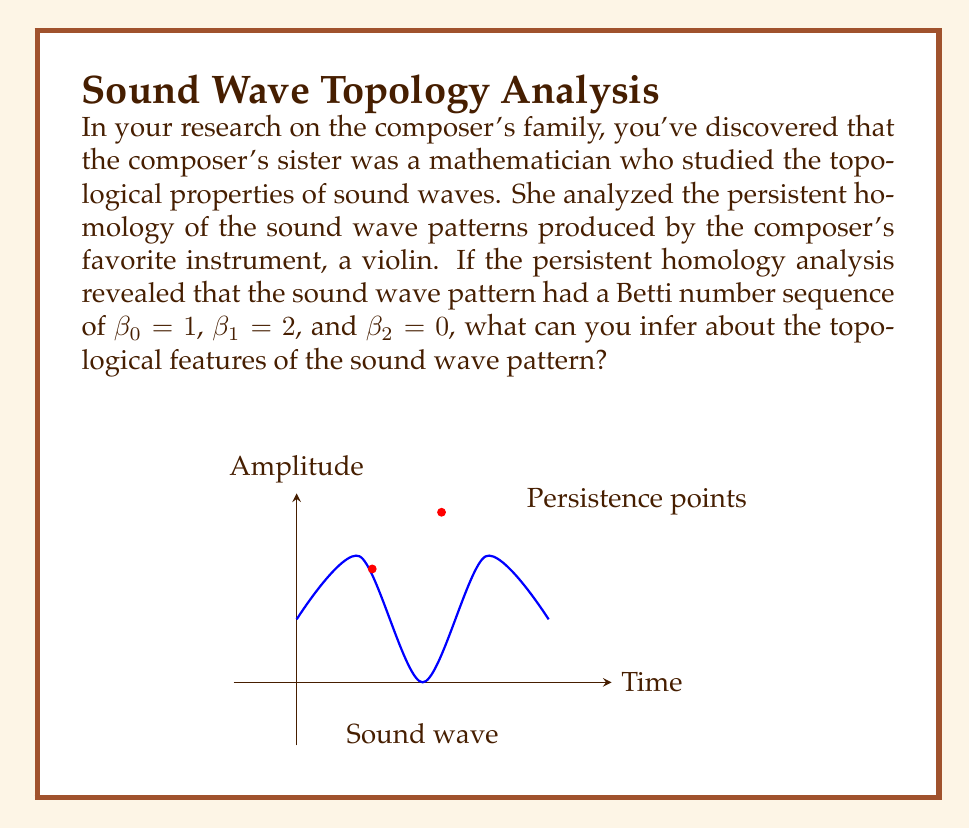Solve this math problem. To interpret the Betti number sequence in the context of persistent homology for sound wave patterns, let's break it down step-by-step:

1) Betti numbers in persistent homology represent different topological features:
   - $\beta_0$ represents the number of connected components
   - $\beta_1$ represents the number of 1-dimensional holes or loops
   - $\beta_2$ represents the number of 2-dimensional voids or cavities

2) In this case, we have:
   - $\beta_0 = 1$: This indicates that there is one connected component. For a sound wave, this is expected as it's typically a single continuous pattern.
   
   - $\beta_1 = 2$: This suggests that there are two persistent 1-dimensional holes or loops in the topological structure of the sound wave pattern. In the context of sound waves, these could represent recurring patterns or cycles in the waveform that persist over time.
   
   - $\beta_2 = 0$: This means there are no 2-dimensional voids. This is also expected for a sound wave, which is essentially a 1-dimensional signal over time.

3) The presence of two 1-dimensional holes ($\beta_1 = 2$) is particularly interesting. In sound wave analysis, this could indicate:
   - Two distinct frequency components that persist throughout the sound
   - A complex harmonic structure with two dominant overtones
   - Two recurring patterns in the amplitude envelope of the sound

4) For a violin, which is known for its rich harmonic content, these topological features might correspond to:
   - The fundamental frequency of the note being played
   - A strong presence of the first or second harmonic
   - A characteristic resonance of the violin's body

5) The persistence of these features (indicated by their appearance in the Betti numbers) suggests that they are stable characteristics of the sound, not transient effects.

Therefore, we can infer that the sound wave pattern has a consistent overall structure (one connected component) with two significant recurring features or cycles, likely related to the harmonic content or resonance characteristics of the violin.
Answer: The sound wave has one connected component and two persistent 1-dimensional cycles, likely representing dominant frequency components or recurring amplitude patterns in the violin's sound. 